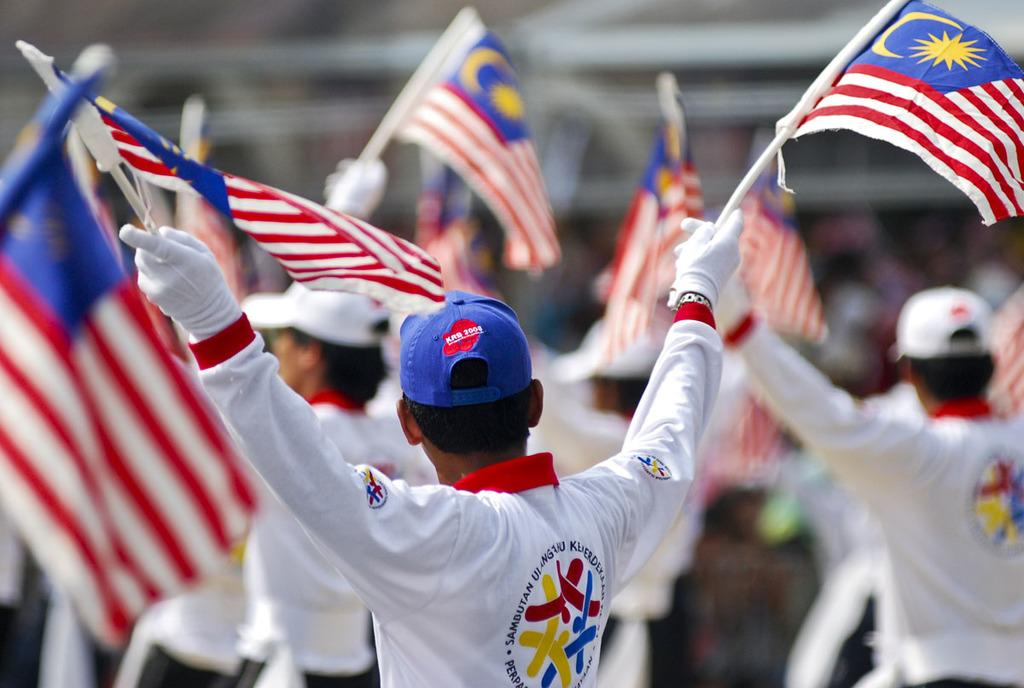Who or what is present in the image? There are people in the image. What are the people holding in the image? The people are holding flags. Can you describe the background of the image? The background of the image is blurred. What color are the minister's eyes in the image? There is no minister present in the image, so it is not possible to determine the color of their eyes. 